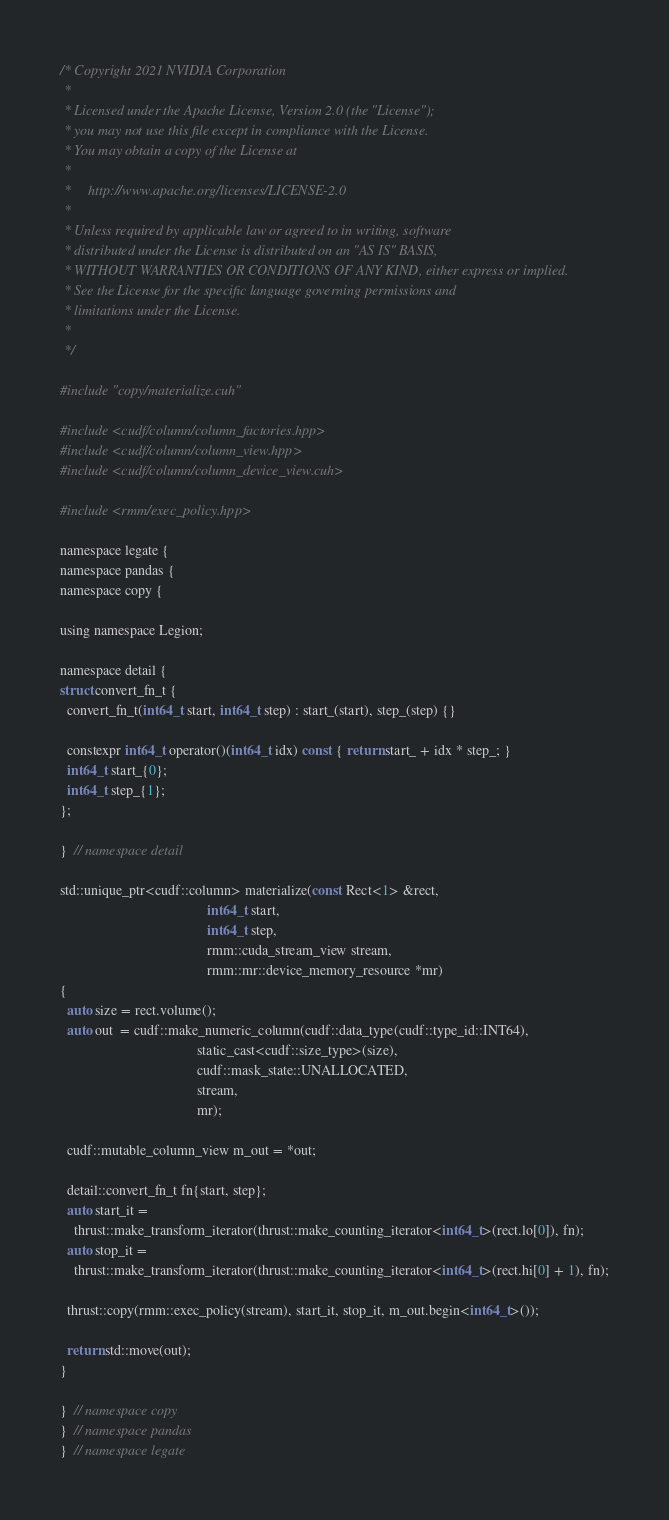Convert code to text. <code><loc_0><loc_0><loc_500><loc_500><_Cuda_>/* Copyright 2021 NVIDIA Corporation
 *
 * Licensed under the Apache License, Version 2.0 (the "License");
 * you may not use this file except in compliance with the License.
 * You may obtain a copy of the License at
 *
 *     http://www.apache.org/licenses/LICENSE-2.0
 *
 * Unless required by applicable law or agreed to in writing, software
 * distributed under the License is distributed on an "AS IS" BASIS,
 * WITHOUT WARRANTIES OR CONDITIONS OF ANY KIND, either express or implied.
 * See the License for the specific language governing permissions and
 * limitations under the License.
 *
 */

#include "copy/materialize.cuh"

#include <cudf/column/column_factories.hpp>
#include <cudf/column/column_view.hpp>
#include <cudf/column/column_device_view.cuh>

#include <rmm/exec_policy.hpp>

namespace legate {
namespace pandas {
namespace copy {

using namespace Legion;

namespace detail {
struct convert_fn_t {
  convert_fn_t(int64_t start, int64_t step) : start_(start), step_(step) {}

  constexpr int64_t operator()(int64_t idx) const { return start_ + idx * step_; }
  int64_t start_{0};
  int64_t step_{1};
};

}  // namespace detail

std::unique_ptr<cudf::column> materialize(const Rect<1> &rect,
                                          int64_t start,
                                          int64_t step,
                                          rmm::cuda_stream_view stream,
                                          rmm::mr::device_memory_resource *mr)
{
  auto size = rect.volume();
  auto out  = cudf::make_numeric_column(cudf::data_type(cudf::type_id::INT64),
                                       static_cast<cudf::size_type>(size),
                                       cudf::mask_state::UNALLOCATED,
                                       stream,
                                       mr);

  cudf::mutable_column_view m_out = *out;

  detail::convert_fn_t fn{start, step};
  auto start_it =
    thrust::make_transform_iterator(thrust::make_counting_iterator<int64_t>(rect.lo[0]), fn);
  auto stop_it =
    thrust::make_transform_iterator(thrust::make_counting_iterator<int64_t>(rect.hi[0] + 1), fn);

  thrust::copy(rmm::exec_policy(stream), start_it, stop_it, m_out.begin<int64_t>());

  return std::move(out);
}

}  // namespace copy
}  // namespace pandas
}  // namespace legate
</code> 